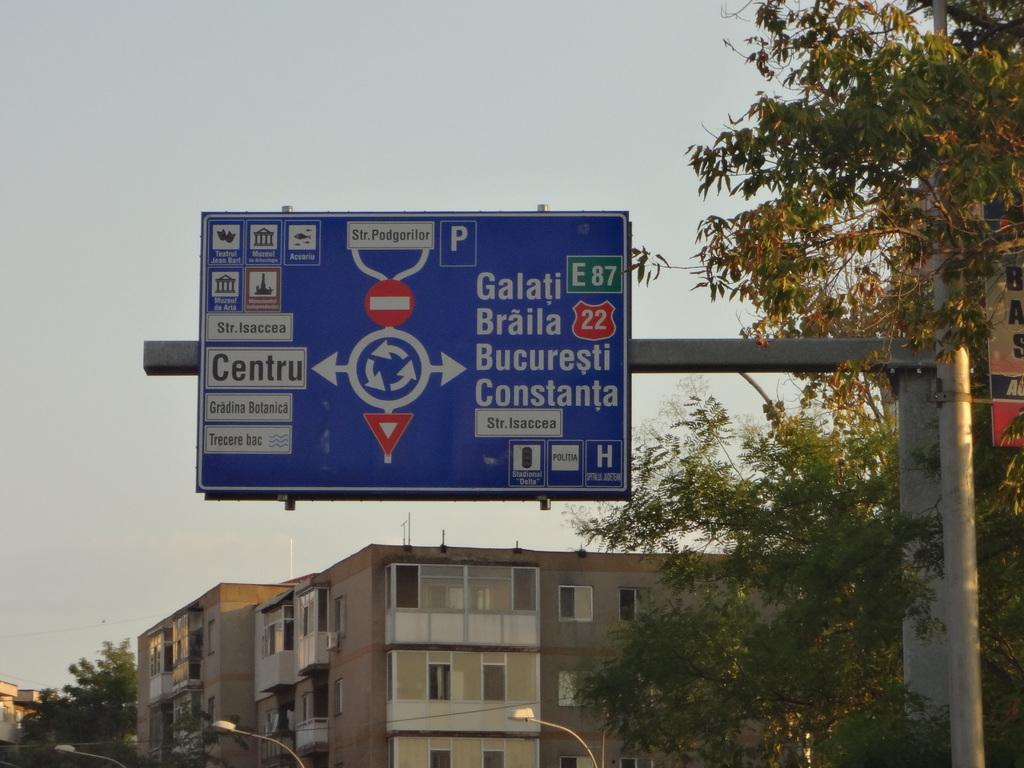<image>
Relay a brief, clear account of the picture shown. A traffic sign with directions to different places such as Braila. 